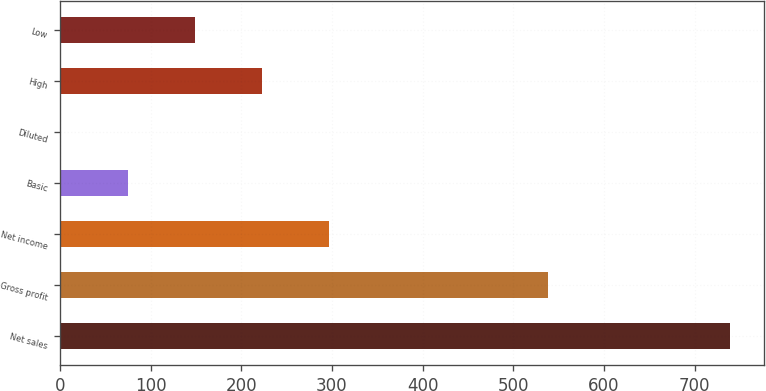Convert chart to OTSL. <chart><loc_0><loc_0><loc_500><loc_500><bar_chart><fcel>Net sales<fcel>Gross profit<fcel>Net income<fcel>Basic<fcel>Diluted<fcel>High<fcel>Low<nl><fcel>739.4<fcel>538<fcel>296.15<fcel>74.53<fcel>0.65<fcel>222.28<fcel>148.41<nl></chart> 